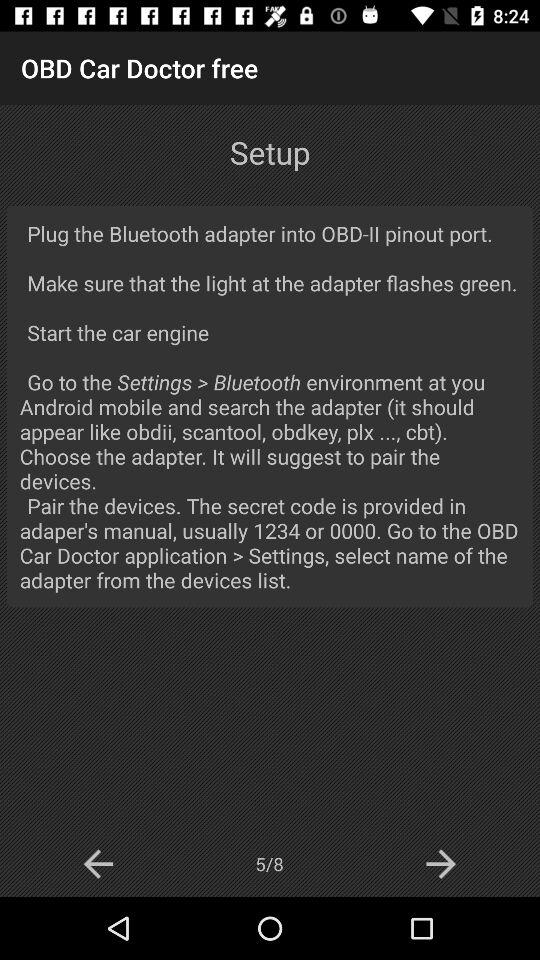On which page is the person? The person is on the setup page. 